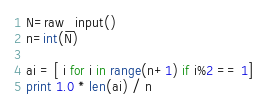<code> <loc_0><loc_0><loc_500><loc_500><_Python_>N=raw_input()
n=int(N)

ai = [ i for i in range(n+1) if i%2 == 1]
print 1.0 * len(ai) / n</code> 